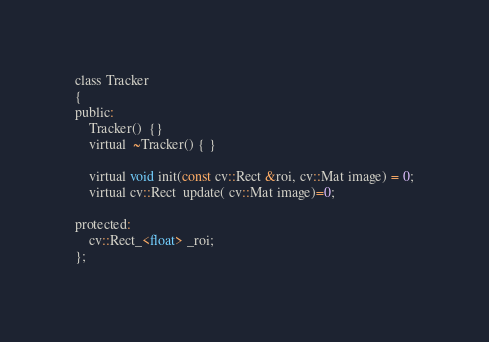<code> <loc_0><loc_0><loc_500><loc_500><_C_>
class Tracker
{
public:
    Tracker()  {}
    virtual  ~Tracker() { }

    virtual void init(const cv::Rect &roi, cv::Mat image) = 0;
    virtual cv::Rect  update( cv::Mat image)=0;

protected:
    cv::Rect_<float> _roi;
};</code> 